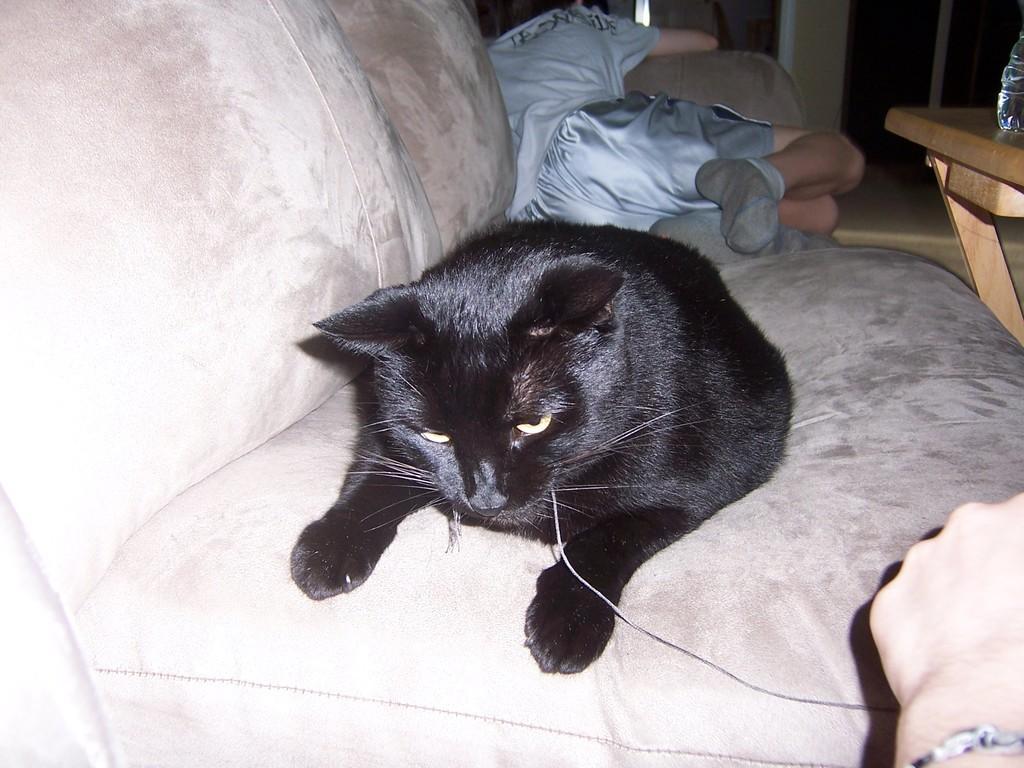How would you summarize this image in a sentence or two? In this picture we can see a person sleeping and a cat sitting on a couch. Near to the couch we can see a table and on the table there is a bottle. At the right side of the pictures i can see partial part of a person´s hand , wearing a watch and holding a thread of a cat. 